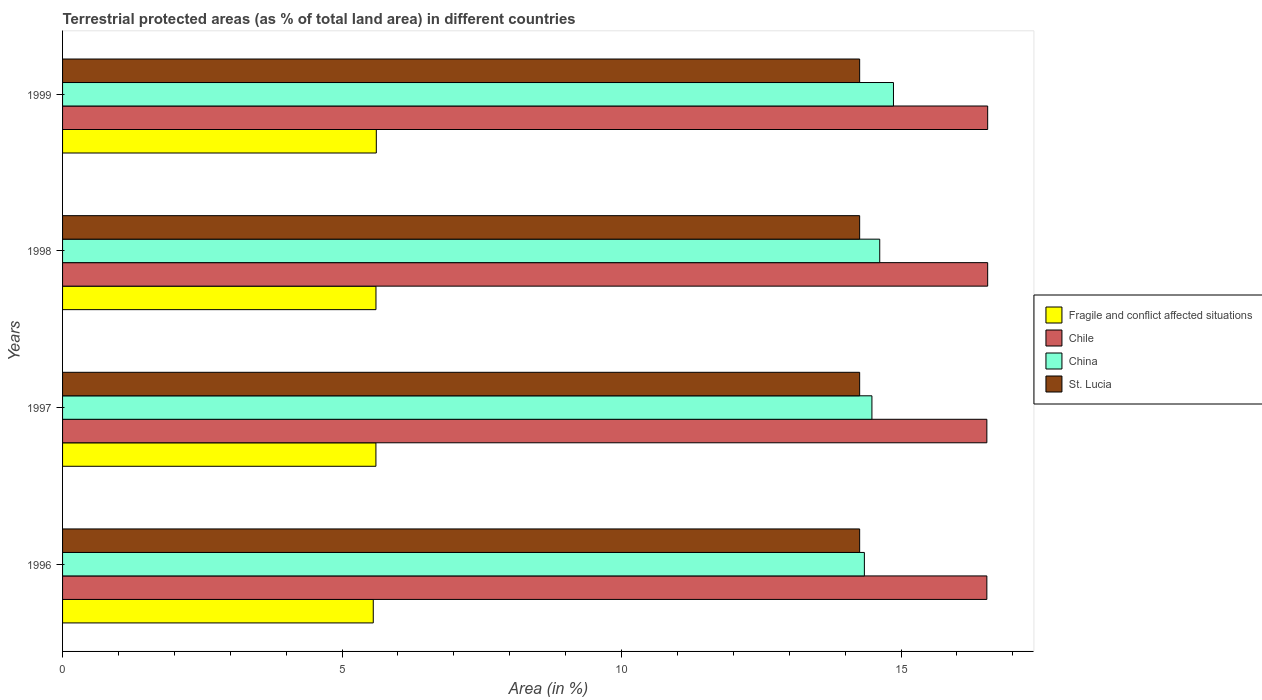How many different coloured bars are there?
Your answer should be very brief. 4. Are the number of bars per tick equal to the number of legend labels?
Ensure brevity in your answer.  Yes. Are the number of bars on each tick of the Y-axis equal?
Your answer should be compact. Yes. How many bars are there on the 2nd tick from the top?
Your answer should be compact. 4. How many bars are there on the 1st tick from the bottom?
Provide a short and direct response. 4. What is the label of the 3rd group of bars from the top?
Your response must be concise. 1997. In how many cases, is the number of bars for a given year not equal to the number of legend labels?
Offer a terse response. 0. What is the percentage of terrestrial protected land in Chile in 1999?
Provide a short and direct response. 16.55. Across all years, what is the maximum percentage of terrestrial protected land in Chile?
Provide a succinct answer. 16.55. Across all years, what is the minimum percentage of terrestrial protected land in Chile?
Make the answer very short. 16.54. In which year was the percentage of terrestrial protected land in St. Lucia maximum?
Provide a short and direct response. 1996. What is the total percentage of terrestrial protected land in Chile in the graph?
Give a very brief answer. 66.17. What is the difference between the percentage of terrestrial protected land in St. Lucia in 1997 and that in 1999?
Keep it short and to the point. 0. What is the difference between the percentage of terrestrial protected land in St. Lucia in 1996 and the percentage of terrestrial protected land in China in 1999?
Your answer should be very brief. -0.6. What is the average percentage of terrestrial protected land in Chile per year?
Your response must be concise. 16.54. In the year 1998, what is the difference between the percentage of terrestrial protected land in St. Lucia and percentage of terrestrial protected land in Chile?
Your answer should be compact. -2.29. What is the ratio of the percentage of terrestrial protected land in Chile in 1998 to that in 1999?
Your answer should be very brief. 1. Is the percentage of terrestrial protected land in Fragile and conflict affected situations in 1996 less than that in 1999?
Your answer should be very brief. Yes. Is the difference between the percentage of terrestrial protected land in St. Lucia in 1996 and 1997 greater than the difference between the percentage of terrestrial protected land in Chile in 1996 and 1997?
Keep it short and to the point. Yes. What is the difference between the highest and the second highest percentage of terrestrial protected land in Fragile and conflict affected situations?
Make the answer very short. 0.01. What is the difference between the highest and the lowest percentage of terrestrial protected land in Fragile and conflict affected situations?
Provide a succinct answer. 0.05. Is the sum of the percentage of terrestrial protected land in China in 1997 and 1998 greater than the maximum percentage of terrestrial protected land in Fragile and conflict affected situations across all years?
Make the answer very short. Yes. What does the 2nd bar from the top in 1996 represents?
Offer a terse response. China. What does the 1st bar from the bottom in 1996 represents?
Offer a very short reply. Fragile and conflict affected situations. How many years are there in the graph?
Your answer should be very brief. 4. Does the graph contain any zero values?
Your answer should be very brief. No. What is the title of the graph?
Your response must be concise. Terrestrial protected areas (as % of total land area) in different countries. What is the label or title of the X-axis?
Offer a terse response. Area (in %). What is the Area (in %) of Fragile and conflict affected situations in 1996?
Provide a short and direct response. 5.56. What is the Area (in %) of Chile in 1996?
Keep it short and to the point. 16.54. What is the Area (in %) in China in 1996?
Make the answer very short. 14.34. What is the Area (in %) of St. Lucia in 1996?
Your answer should be very brief. 14.26. What is the Area (in %) of Fragile and conflict affected situations in 1997?
Provide a succinct answer. 5.61. What is the Area (in %) in Chile in 1997?
Offer a very short reply. 16.54. What is the Area (in %) of China in 1997?
Your answer should be very brief. 14.48. What is the Area (in %) in St. Lucia in 1997?
Your response must be concise. 14.26. What is the Area (in %) in Fragile and conflict affected situations in 1998?
Keep it short and to the point. 5.61. What is the Area (in %) of Chile in 1998?
Your answer should be compact. 16.55. What is the Area (in %) of China in 1998?
Ensure brevity in your answer.  14.62. What is the Area (in %) in St. Lucia in 1998?
Provide a short and direct response. 14.26. What is the Area (in %) of Fragile and conflict affected situations in 1999?
Offer a very short reply. 5.61. What is the Area (in %) in Chile in 1999?
Ensure brevity in your answer.  16.55. What is the Area (in %) in China in 1999?
Provide a succinct answer. 14.86. What is the Area (in %) of St. Lucia in 1999?
Make the answer very short. 14.26. Across all years, what is the maximum Area (in %) of Fragile and conflict affected situations?
Provide a short and direct response. 5.61. Across all years, what is the maximum Area (in %) in Chile?
Offer a very short reply. 16.55. Across all years, what is the maximum Area (in %) of China?
Offer a terse response. 14.86. Across all years, what is the maximum Area (in %) in St. Lucia?
Give a very brief answer. 14.26. Across all years, what is the minimum Area (in %) in Fragile and conflict affected situations?
Give a very brief answer. 5.56. Across all years, what is the minimum Area (in %) in Chile?
Make the answer very short. 16.54. Across all years, what is the minimum Area (in %) in China?
Make the answer very short. 14.34. Across all years, what is the minimum Area (in %) of St. Lucia?
Give a very brief answer. 14.26. What is the total Area (in %) of Fragile and conflict affected situations in the graph?
Give a very brief answer. 22.38. What is the total Area (in %) of Chile in the graph?
Offer a very short reply. 66.17. What is the total Area (in %) in China in the graph?
Provide a short and direct response. 58.31. What is the total Area (in %) in St. Lucia in the graph?
Your response must be concise. 57.04. What is the difference between the Area (in %) of Fragile and conflict affected situations in 1996 and that in 1997?
Make the answer very short. -0.05. What is the difference between the Area (in %) in China in 1996 and that in 1997?
Make the answer very short. -0.13. What is the difference between the Area (in %) of St. Lucia in 1996 and that in 1997?
Make the answer very short. 0. What is the difference between the Area (in %) in Fragile and conflict affected situations in 1996 and that in 1998?
Ensure brevity in your answer.  -0.05. What is the difference between the Area (in %) of Chile in 1996 and that in 1998?
Keep it short and to the point. -0.01. What is the difference between the Area (in %) of China in 1996 and that in 1998?
Your answer should be very brief. -0.27. What is the difference between the Area (in %) of Fragile and conflict affected situations in 1996 and that in 1999?
Offer a terse response. -0.05. What is the difference between the Area (in %) in Chile in 1996 and that in 1999?
Your response must be concise. -0.01. What is the difference between the Area (in %) of China in 1996 and that in 1999?
Provide a short and direct response. -0.52. What is the difference between the Area (in %) of Fragile and conflict affected situations in 1997 and that in 1998?
Give a very brief answer. -0. What is the difference between the Area (in %) of Chile in 1997 and that in 1998?
Provide a short and direct response. -0.01. What is the difference between the Area (in %) of China in 1997 and that in 1998?
Offer a terse response. -0.14. What is the difference between the Area (in %) in St. Lucia in 1997 and that in 1998?
Provide a short and direct response. 0. What is the difference between the Area (in %) in Fragile and conflict affected situations in 1997 and that in 1999?
Your answer should be very brief. -0.01. What is the difference between the Area (in %) of Chile in 1997 and that in 1999?
Ensure brevity in your answer.  -0.01. What is the difference between the Area (in %) in China in 1997 and that in 1999?
Keep it short and to the point. -0.39. What is the difference between the Area (in %) of Fragile and conflict affected situations in 1998 and that in 1999?
Keep it short and to the point. -0.01. What is the difference between the Area (in %) in China in 1998 and that in 1999?
Make the answer very short. -0.25. What is the difference between the Area (in %) of St. Lucia in 1998 and that in 1999?
Offer a very short reply. 0. What is the difference between the Area (in %) in Fragile and conflict affected situations in 1996 and the Area (in %) in Chile in 1997?
Provide a succinct answer. -10.98. What is the difference between the Area (in %) of Fragile and conflict affected situations in 1996 and the Area (in %) of China in 1997?
Provide a succinct answer. -8.92. What is the difference between the Area (in %) of Fragile and conflict affected situations in 1996 and the Area (in %) of St. Lucia in 1997?
Provide a short and direct response. -8.7. What is the difference between the Area (in %) of Chile in 1996 and the Area (in %) of China in 1997?
Provide a short and direct response. 2.06. What is the difference between the Area (in %) of Chile in 1996 and the Area (in %) of St. Lucia in 1997?
Give a very brief answer. 2.28. What is the difference between the Area (in %) of China in 1996 and the Area (in %) of St. Lucia in 1997?
Make the answer very short. 0.08. What is the difference between the Area (in %) of Fragile and conflict affected situations in 1996 and the Area (in %) of Chile in 1998?
Offer a terse response. -10.99. What is the difference between the Area (in %) of Fragile and conflict affected situations in 1996 and the Area (in %) of China in 1998?
Ensure brevity in your answer.  -9.06. What is the difference between the Area (in %) in Fragile and conflict affected situations in 1996 and the Area (in %) in St. Lucia in 1998?
Make the answer very short. -8.7. What is the difference between the Area (in %) of Chile in 1996 and the Area (in %) of China in 1998?
Your response must be concise. 1.92. What is the difference between the Area (in %) of Chile in 1996 and the Area (in %) of St. Lucia in 1998?
Keep it short and to the point. 2.28. What is the difference between the Area (in %) of China in 1996 and the Area (in %) of St. Lucia in 1998?
Provide a short and direct response. 0.08. What is the difference between the Area (in %) in Fragile and conflict affected situations in 1996 and the Area (in %) in Chile in 1999?
Provide a short and direct response. -10.99. What is the difference between the Area (in %) of Fragile and conflict affected situations in 1996 and the Area (in %) of China in 1999?
Your response must be concise. -9.31. What is the difference between the Area (in %) of Fragile and conflict affected situations in 1996 and the Area (in %) of St. Lucia in 1999?
Make the answer very short. -8.7. What is the difference between the Area (in %) in Chile in 1996 and the Area (in %) in China in 1999?
Give a very brief answer. 1.67. What is the difference between the Area (in %) in Chile in 1996 and the Area (in %) in St. Lucia in 1999?
Your answer should be very brief. 2.28. What is the difference between the Area (in %) in China in 1996 and the Area (in %) in St. Lucia in 1999?
Your answer should be compact. 0.08. What is the difference between the Area (in %) in Fragile and conflict affected situations in 1997 and the Area (in %) in Chile in 1998?
Provide a short and direct response. -10.94. What is the difference between the Area (in %) of Fragile and conflict affected situations in 1997 and the Area (in %) of China in 1998?
Your response must be concise. -9.01. What is the difference between the Area (in %) in Fragile and conflict affected situations in 1997 and the Area (in %) in St. Lucia in 1998?
Keep it short and to the point. -8.65. What is the difference between the Area (in %) in Chile in 1997 and the Area (in %) in China in 1998?
Keep it short and to the point. 1.92. What is the difference between the Area (in %) of Chile in 1997 and the Area (in %) of St. Lucia in 1998?
Offer a very short reply. 2.28. What is the difference between the Area (in %) in China in 1997 and the Area (in %) in St. Lucia in 1998?
Your answer should be compact. 0.22. What is the difference between the Area (in %) in Fragile and conflict affected situations in 1997 and the Area (in %) in Chile in 1999?
Keep it short and to the point. -10.94. What is the difference between the Area (in %) of Fragile and conflict affected situations in 1997 and the Area (in %) of China in 1999?
Offer a terse response. -9.26. What is the difference between the Area (in %) of Fragile and conflict affected situations in 1997 and the Area (in %) of St. Lucia in 1999?
Offer a very short reply. -8.65. What is the difference between the Area (in %) of Chile in 1997 and the Area (in %) of China in 1999?
Your answer should be very brief. 1.67. What is the difference between the Area (in %) in Chile in 1997 and the Area (in %) in St. Lucia in 1999?
Give a very brief answer. 2.28. What is the difference between the Area (in %) in China in 1997 and the Area (in %) in St. Lucia in 1999?
Offer a very short reply. 0.22. What is the difference between the Area (in %) in Fragile and conflict affected situations in 1998 and the Area (in %) in Chile in 1999?
Your answer should be compact. -10.94. What is the difference between the Area (in %) in Fragile and conflict affected situations in 1998 and the Area (in %) in China in 1999?
Provide a short and direct response. -9.26. What is the difference between the Area (in %) in Fragile and conflict affected situations in 1998 and the Area (in %) in St. Lucia in 1999?
Offer a very short reply. -8.65. What is the difference between the Area (in %) in Chile in 1998 and the Area (in %) in China in 1999?
Make the answer very short. 1.69. What is the difference between the Area (in %) in Chile in 1998 and the Area (in %) in St. Lucia in 1999?
Offer a very short reply. 2.29. What is the difference between the Area (in %) of China in 1998 and the Area (in %) of St. Lucia in 1999?
Keep it short and to the point. 0.36. What is the average Area (in %) of Fragile and conflict affected situations per year?
Keep it short and to the point. 5.6. What is the average Area (in %) in Chile per year?
Your answer should be compact. 16.54. What is the average Area (in %) in China per year?
Offer a very short reply. 14.58. What is the average Area (in %) of St. Lucia per year?
Make the answer very short. 14.26. In the year 1996, what is the difference between the Area (in %) in Fragile and conflict affected situations and Area (in %) in Chile?
Offer a terse response. -10.98. In the year 1996, what is the difference between the Area (in %) of Fragile and conflict affected situations and Area (in %) of China?
Keep it short and to the point. -8.79. In the year 1996, what is the difference between the Area (in %) in Fragile and conflict affected situations and Area (in %) in St. Lucia?
Keep it short and to the point. -8.7. In the year 1996, what is the difference between the Area (in %) in Chile and Area (in %) in China?
Your answer should be compact. 2.19. In the year 1996, what is the difference between the Area (in %) in Chile and Area (in %) in St. Lucia?
Offer a very short reply. 2.28. In the year 1996, what is the difference between the Area (in %) of China and Area (in %) of St. Lucia?
Ensure brevity in your answer.  0.08. In the year 1997, what is the difference between the Area (in %) in Fragile and conflict affected situations and Area (in %) in Chile?
Your response must be concise. -10.93. In the year 1997, what is the difference between the Area (in %) of Fragile and conflict affected situations and Area (in %) of China?
Offer a terse response. -8.87. In the year 1997, what is the difference between the Area (in %) of Fragile and conflict affected situations and Area (in %) of St. Lucia?
Provide a short and direct response. -8.65. In the year 1997, what is the difference between the Area (in %) in Chile and Area (in %) in China?
Provide a short and direct response. 2.06. In the year 1997, what is the difference between the Area (in %) of Chile and Area (in %) of St. Lucia?
Ensure brevity in your answer.  2.28. In the year 1997, what is the difference between the Area (in %) in China and Area (in %) in St. Lucia?
Your response must be concise. 0.22. In the year 1998, what is the difference between the Area (in %) in Fragile and conflict affected situations and Area (in %) in Chile?
Keep it short and to the point. -10.94. In the year 1998, what is the difference between the Area (in %) in Fragile and conflict affected situations and Area (in %) in China?
Provide a succinct answer. -9.01. In the year 1998, what is the difference between the Area (in %) in Fragile and conflict affected situations and Area (in %) in St. Lucia?
Provide a succinct answer. -8.65. In the year 1998, what is the difference between the Area (in %) in Chile and Area (in %) in China?
Your answer should be very brief. 1.93. In the year 1998, what is the difference between the Area (in %) in Chile and Area (in %) in St. Lucia?
Provide a short and direct response. 2.29. In the year 1998, what is the difference between the Area (in %) of China and Area (in %) of St. Lucia?
Keep it short and to the point. 0.36. In the year 1999, what is the difference between the Area (in %) of Fragile and conflict affected situations and Area (in %) of Chile?
Give a very brief answer. -10.94. In the year 1999, what is the difference between the Area (in %) of Fragile and conflict affected situations and Area (in %) of China?
Your answer should be very brief. -9.25. In the year 1999, what is the difference between the Area (in %) of Fragile and conflict affected situations and Area (in %) of St. Lucia?
Provide a short and direct response. -8.65. In the year 1999, what is the difference between the Area (in %) in Chile and Area (in %) in China?
Make the answer very short. 1.69. In the year 1999, what is the difference between the Area (in %) in Chile and Area (in %) in St. Lucia?
Offer a terse response. 2.29. In the year 1999, what is the difference between the Area (in %) of China and Area (in %) of St. Lucia?
Your response must be concise. 0.6. What is the ratio of the Area (in %) of Chile in 1996 to that in 1997?
Keep it short and to the point. 1. What is the ratio of the Area (in %) of China in 1996 to that in 1997?
Provide a succinct answer. 0.99. What is the ratio of the Area (in %) in Fragile and conflict affected situations in 1996 to that in 1998?
Give a very brief answer. 0.99. What is the ratio of the Area (in %) of China in 1996 to that in 1998?
Your response must be concise. 0.98. What is the ratio of the Area (in %) in St. Lucia in 1996 to that in 1998?
Your answer should be very brief. 1. What is the ratio of the Area (in %) in Fragile and conflict affected situations in 1996 to that in 1999?
Your answer should be compact. 0.99. What is the ratio of the Area (in %) of China in 1996 to that in 1999?
Your answer should be compact. 0.96. What is the ratio of the Area (in %) of St. Lucia in 1996 to that in 1999?
Offer a terse response. 1. What is the ratio of the Area (in %) in Fragile and conflict affected situations in 1997 to that in 1998?
Your answer should be very brief. 1. What is the ratio of the Area (in %) of China in 1997 to that in 1998?
Give a very brief answer. 0.99. What is the ratio of the Area (in %) of Chile in 1997 to that in 1999?
Your answer should be compact. 1. What is the ratio of the Area (in %) in China in 1997 to that in 1999?
Your response must be concise. 0.97. What is the ratio of the Area (in %) of Fragile and conflict affected situations in 1998 to that in 1999?
Provide a succinct answer. 1. What is the ratio of the Area (in %) in Chile in 1998 to that in 1999?
Give a very brief answer. 1. What is the ratio of the Area (in %) in China in 1998 to that in 1999?
Make the answer very short. 0.98. What is the difference between the highest and the second highest Area (in %) in Fragile and conflict affected situations?
Provide a short and direct response. 0.01. What is the difference between the highest and the second highest Area (in %) of China?
Offer a terse response. 0.25. What is the difference between the highest and the lowest Area (in %) in Fragile and conflict affected situations?
Keep it short and to the point. 0.05. What is the difference between the highest and the lowest Area (in %) in Chile?
Offer a terse response. 0.01. What is the difference between the highest and the lowest Area (in %) of China?
Offer a very short reply. 0.52. What is the difference between the highest and the lowest Area (in %) in St. Lucia?
Your answer should be very brief. 0. 